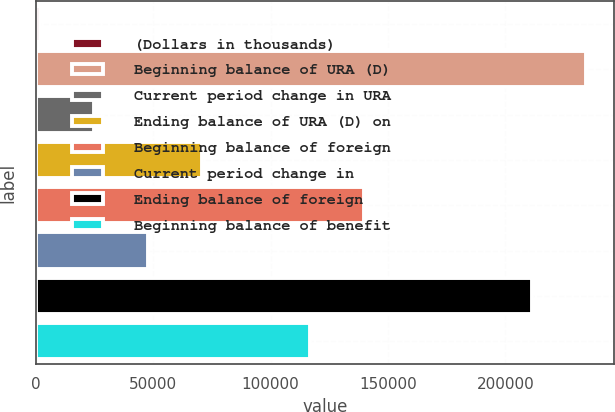Convert chart to OTSL. <chart><loc_0><loc_0><loc_500><loc_500><bar_chart><fcel>(Dollars in thousands)<fcel>Beginning balance of URA (D)<fcel>Current period change in URA<fcel>Ending balance of URA (D) on<fcel>Beginning balance of foreign<fcel>Current period change in<fcel>Ending balance of foreign<fcel>Beginning balance of benefit<nl><fcel>2015<fcel>234451<fcel>24989<fcel>70937<fcel>139859<fcel>47963<fcel>211477<fcel>116885<nl></chart> 